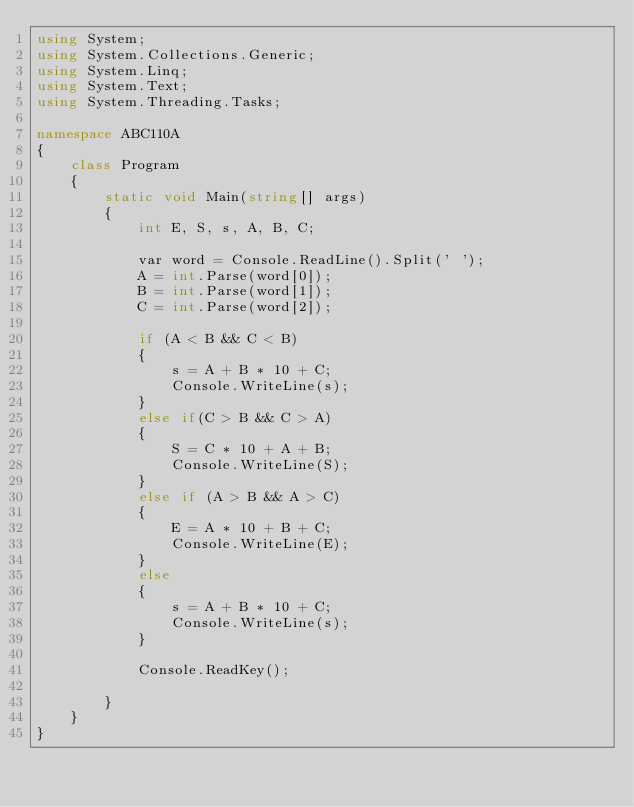Convert code to text. <code><loc_0><loc_0><loc_500><loc_500><_C#_>using System;
using System.Collections.Generic;
using System.Linq;
using System.Text;
using System.Threading.Tasks;

namespace ABC110A
{
    class Program
    {
        static void Main(string[] args)
        {
            int E, S, s, A, B, C;

            var word = Console.ReadLine().Split(' ');
            A = int.Parse(word[0]);
            B = int.Parse(word[1]);
            C = int.Parse(word[2]);

            if (A < B && C < B)
            {
                s = A + B * 10 + C;
                Console.WriteLine(s);
            }
            else if(C > B && C > A)
            {
                S = C * 10 + A + B;
                Console.WriteLine(S);
            }
            else if (A > B && A > C)
            {
                E = A * 10 + B + C;
                Console.WriteLine(E);
            }
            else 
            {
                s = A + B * 10 + C;
                Console.WriteLine(s);                
            }
            
            Console.ReadKey();

        }
    }
}
</code> 